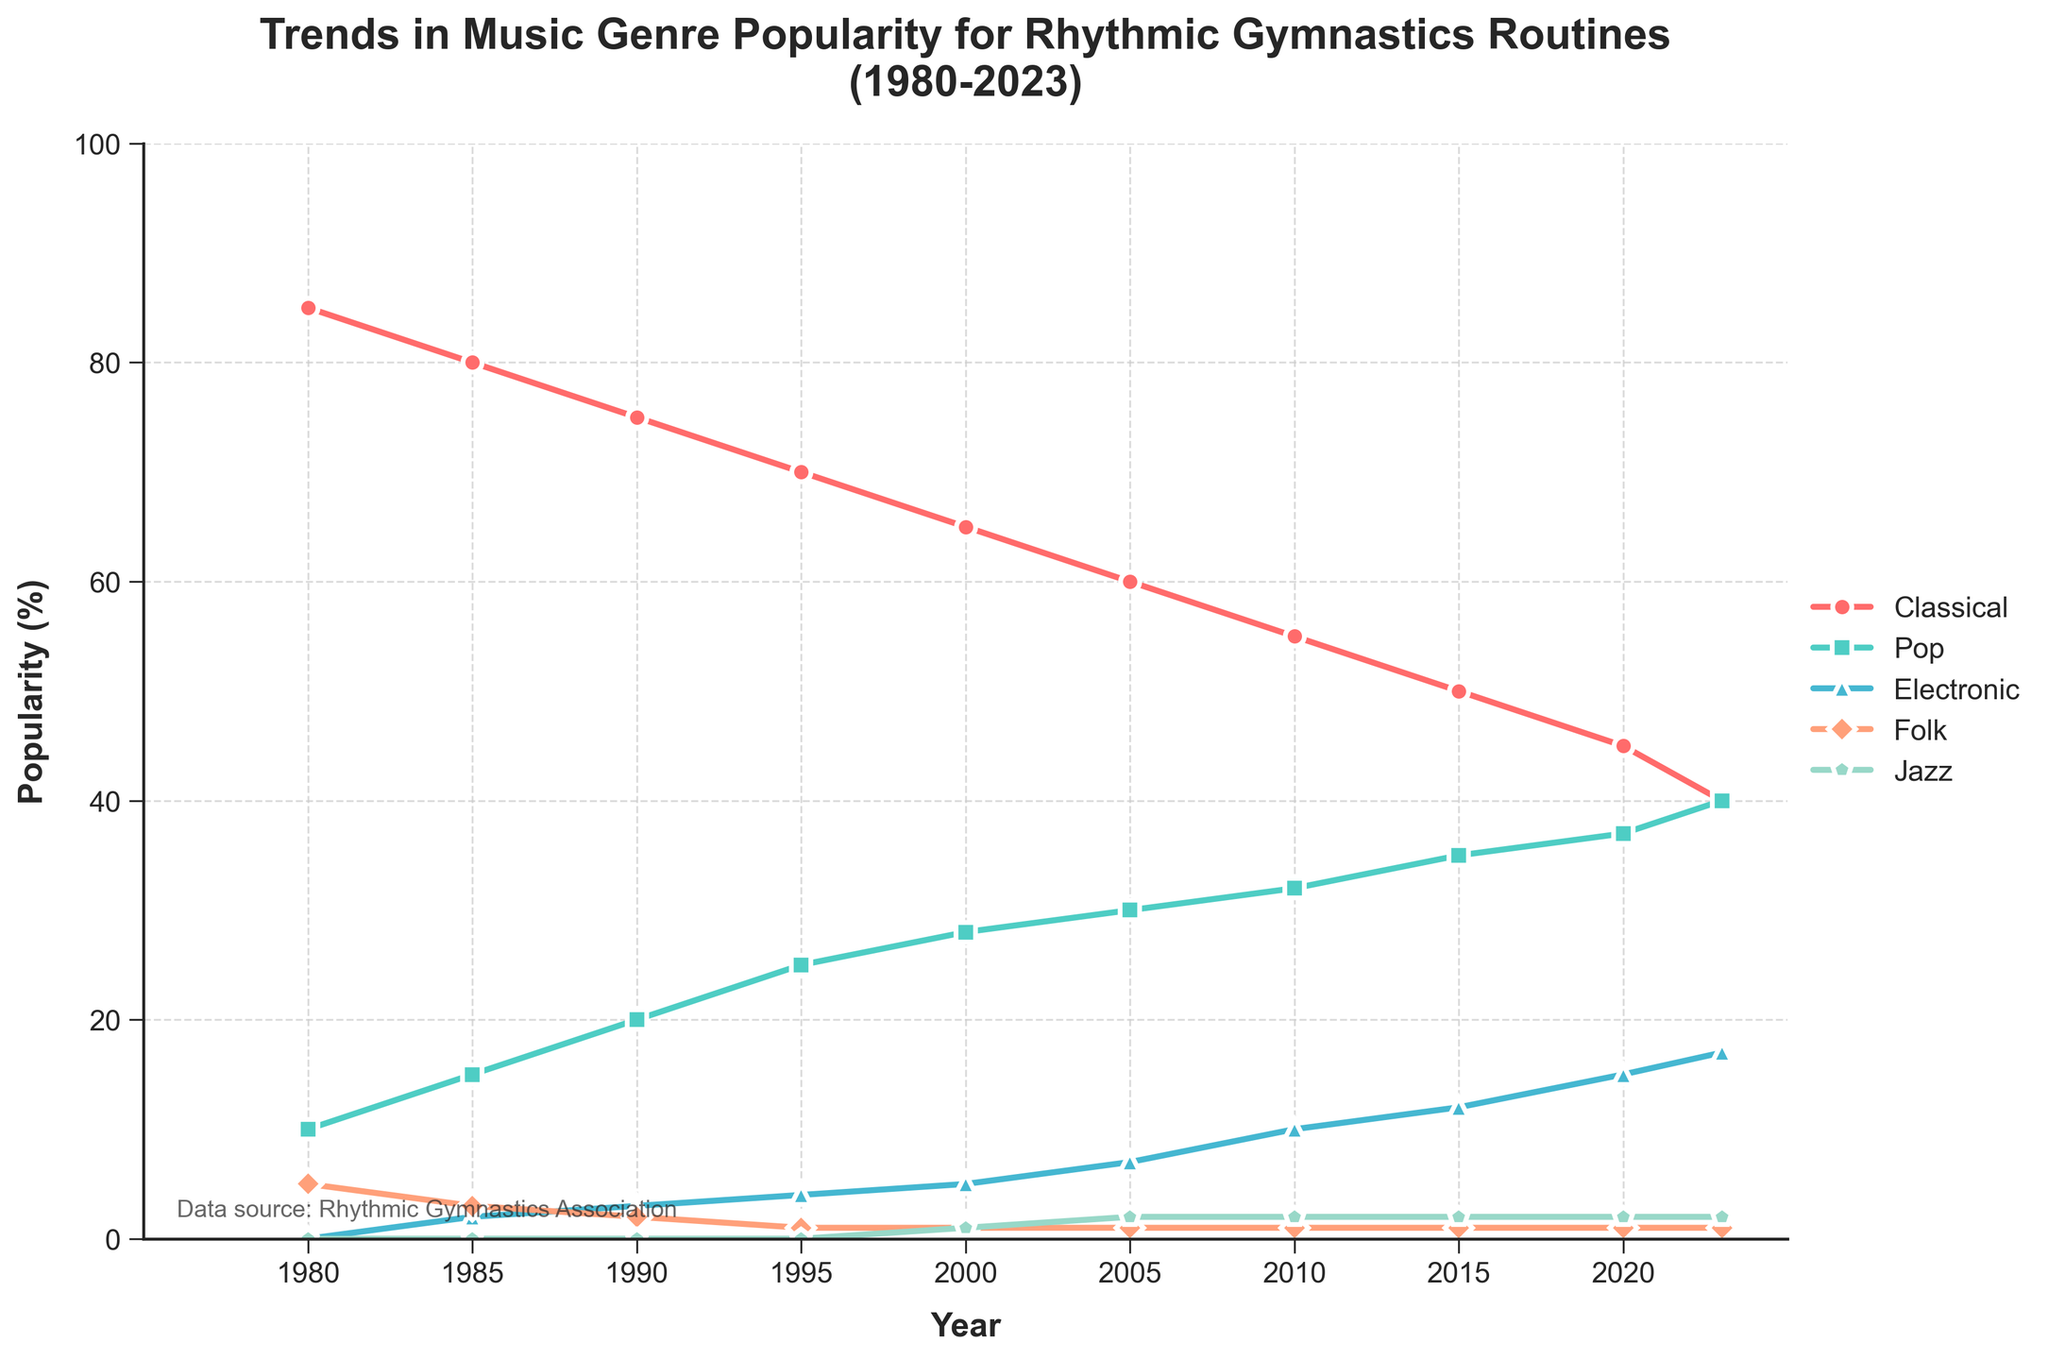What's the overall trend for Classical music from 1980 to 2023? The trend for Classical music shows a steady decline. It starts at 85% in 1980 and decreases continuously to 40% by 2023.
Answer: Decline How did the popularity of Pop music change between 1990 and 2010? Between 1990 and 2010, Pop music increased in popularity. In 1990, Pop music was 20%, and by 2010, it had risen to 32%.
Answer: Increased Which genre experienced the greatest growth between 1980 and 2023? Electronic music experienced the greatest growth, starting from 0% in 1980 and rising to 17% by 2023.
Answer: Electronic What is the difference in popularity between Folk and Jazz music in 2023? In 2023, Folk music has a popularity of 1%, and Jazz music has a popularity of 2%. The difference is 2% - 1% = 1%.
Answer: 1% During which five-year period did Classical music see the largest drop in popularity? The largest drop for Classical music occurs between 2015 and 2020, where the percentage drops by 5% (from 50% to 45%).
Answer: 2015-2020 Compare the popularity of Electronic music in 2005 and 2023, and state the increase in percentage points. In 2005, Electronic music's popularity was 7%, and in 2023, it is 17%. The increase is 17% - 7% = 10%.
Answer: 10% Which genre showed no change in popularity from 1980 to 2023? Folk music showed no change in popularity, remaining at 1% from 1985 onwards.
Answer: Folk What is the combined popularity of Pop and Electronic music in 2010? In 2010, the popularity of Pop is 32% and Electronic is 10%. Their combined popularity is 32% + 10% = 42%.
Answer: 42% How does the popularity of Jazz in 2000 compare to that in 2023? Jazz music slightly increased its popularity from 1% in 2000 to 2% in 2023.
Answer: Slightly increased From 1980 to 2023, which genre has consistently increased in popularity over the years? Pop music has consistently increased in popularity, going from 10% in 1980 to 40% in 2023.
Answer: Pop 